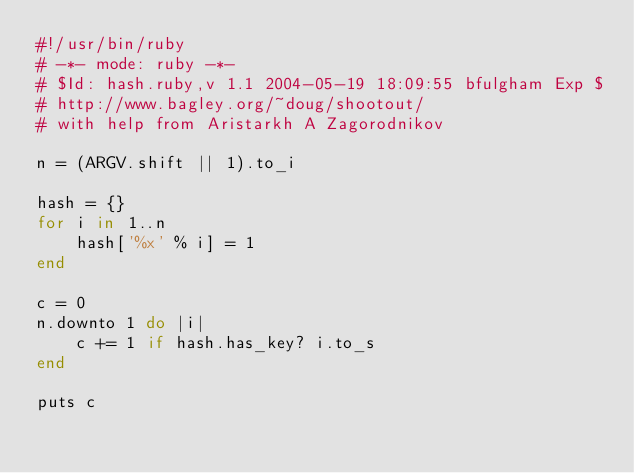Convert code to text. <code><loc_0><loc_0><loc_500><loc_500><_Ruby_>#!/usr/bin/ruby
# -*- mode: ruby -*-
# $Id: hash.ruby,v 1.1 2004-05-19 18:09:55 bfulgham Exp $
# http://www.bagley.org/~doug/shootout/
# with help from Aristarkh A Zagorodnikov

n = (ARGV.shift || 1).to_i

hash = {}
for i in 1..n
    hash['%x' % i] = 1
end

c = 0
n.downto 1 do |i|
    c += 1 if hash.has_key? i.to_s
end

puts c
</code> 